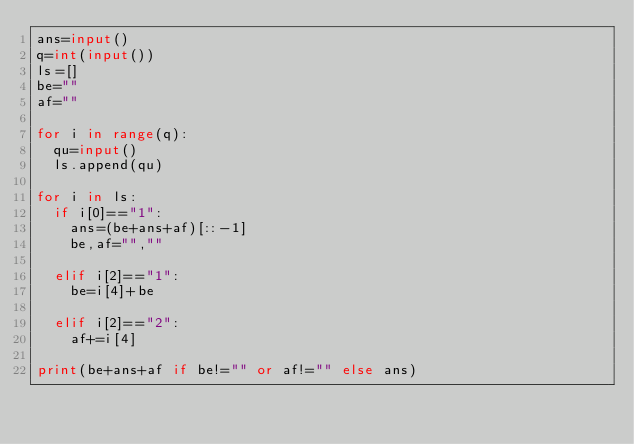Convert code to text. <code><loc_0><loc_0><loc_500><loc_500><_Python_>ans=input()
q=int(input())
ls=[]
be=""
af=""

for i in range(q):
  qu=input()
  ls.append(qu)
  
for i in ls:
  if i[0]=="1":
    ans=(be+ans+af)[::-1]
    be,af="",""
    
  elif i[2]=="1":
    be=i[4]+be
    
  elif i[2]=="2":
    af+=i[4]
      
print(be+ans+af if be!="" or af!="" else ans)</code> 